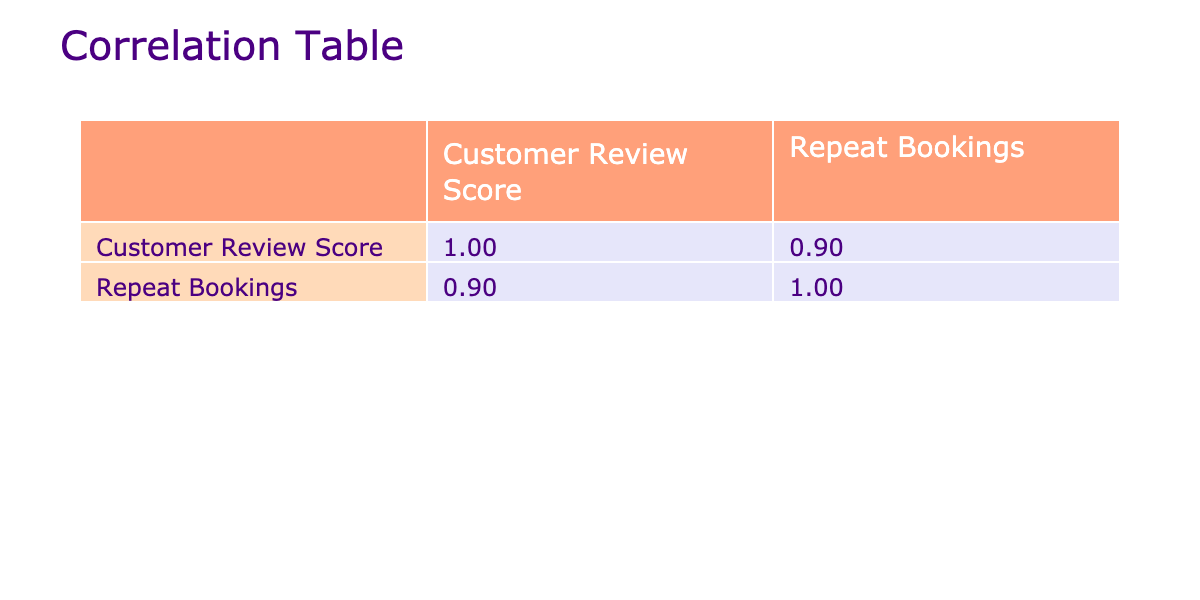What is the customer review score for Reliable Restoration? From the table, the row for Reliable Restoration shows a customer review score listed in the second column. That value is 4.9.
Answer: 4.9 How many repeat bookings did Happy Cleaners have in the last 12 months? The table indicates that Happy Cleaners has a repeat bookings value of 25 listed in the third column.
Answer: 25 Is the customer review score for QuickFix Plumbing greater than 4.5? Upon checking the table, the customer review score for QuickFix Plumbing is exactly 4.5, which means it is not greater than 4.5.
Answer: No What is the average repeat bookings for service providers with a customer review score above 4.5? First, identify the providers with a score above 4.5: Happy Cleaners (25), Reliable Restoration (30), GreenThumb Landscaping (20), BrightSpark Electric (22), Trusted Tutors (28). The total of these values is 25 + 30 + 20 + 22 + 28 = 125. There are 5 providers in total, thus the average is 125 / 5 = 25.
Answer: 25 Are there any providers with a customer review score below 4.5? By reviewing the table, Merry Maids (4.2) and HomeSafe Pest Control (4.3) have scores below 4.5. Therefore, there are providers scoring below 4.5.
Answer: Yes What is the correlation coefficient between customer review scores and repeat bookings? The table calculates the correlation coefficient, which is typically found in the cells provided. Looking at the correlation value between these data points, we find it to be approximately 0.90. This indicates a strong positive correlation.
Answer: 0.90 How many service providers have a customer review score of at least 4.6 and what is their total repeat bookings? The providers with a score of at least 4.6 are Happy Cleaners (25), Reliable Restoration (30), BrightSpark Electric (22), and Trusted Tutors (28), which are a total of 4 providers. Their repeat bookings total is 25 + 30 + 22 + 28 = 105.
Answer: 4 providers; 105 repeat bookings What is the difference in repeat bookings between the provider with the highest score and the provider with the lowest score? Reliable Restoration has the highest score (4.9) with 30 repeat bookings, and Merry Maids has the lowest score (4.2) with 10 repeat bookings. The difference is 30 - 10 = 20.
Answer: 20 